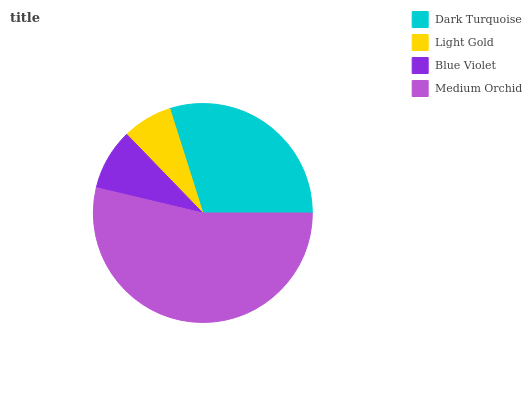Is Light Gold the minimum?
Answer yes or no. Yes. Is Medium Orchid the maximum?
Answer yes or no. Yes. Is Blue Violet the minimum?
Answer yes or no. No. Is Blue Violet the maximum?
Answer yes or no. No. Is Blue Violet greater than Light Gold?
Answer yes or no. Yes. Is Light Gold less than Blue Violet?
Answer yes or no. Yes. Is Light Gold greater than Blue Violet?
Answer yes or no. No. Is Blue Violet less than Light Gold?
Answer yes or no. No. Is Dark Turquoise the high median?
Answer yes or no. Yes. Is Blue Violet the low median?
Answer yes or no. Yes. Is Medium Orchid the high median?
Answer yes or no. No. Is Dark Turquoise the low median?
Answer yes or no. No. 